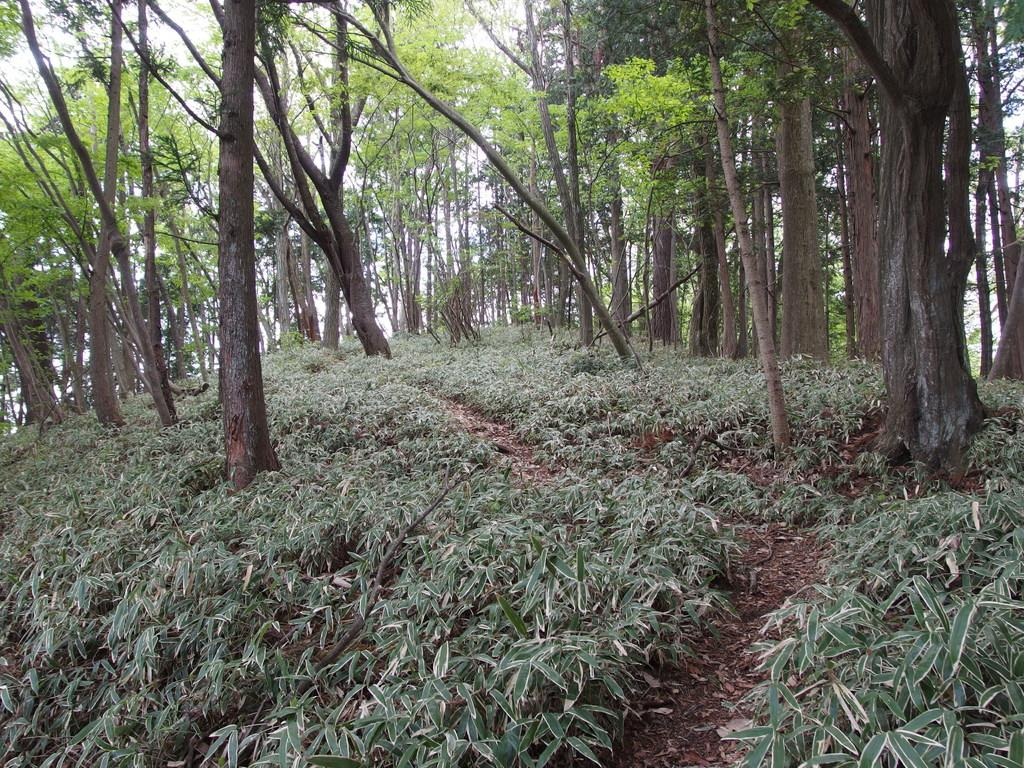What type of natural environment is depicted in the image? The image contains a view of the forest. What are the most prominent features in the front of the image? There are tall trees in the front of the image. What type of vegetation can be seen on the ground in the front bottom side of the image? There are green plants on the ground in the front bottom side of the image. What word is written on the bark of the tallest tree in the image? There are no words written on the trees in the image; the trees have bark but no visible text. 